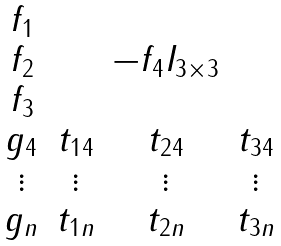<formula> <loc_0><loc_0><loc_500><loc_500>\begin{matrix} f _ { 1 } & & & \\ f _ { 2 } & & - f _ { 4 } I _ { 3 \times 3 } & \\ f _ { 3 } & & & \\ g _ { 4 } & t _ { 1 4 } & t _ { 2 4 } & t _ { 3 4 } \\ \vdots & \vdots & \vdots & \vdots \\ g _ { n } & t _ { 1 n } & t _ { 2 n } & t _ { 3 n } \end{matrix}</formula> 